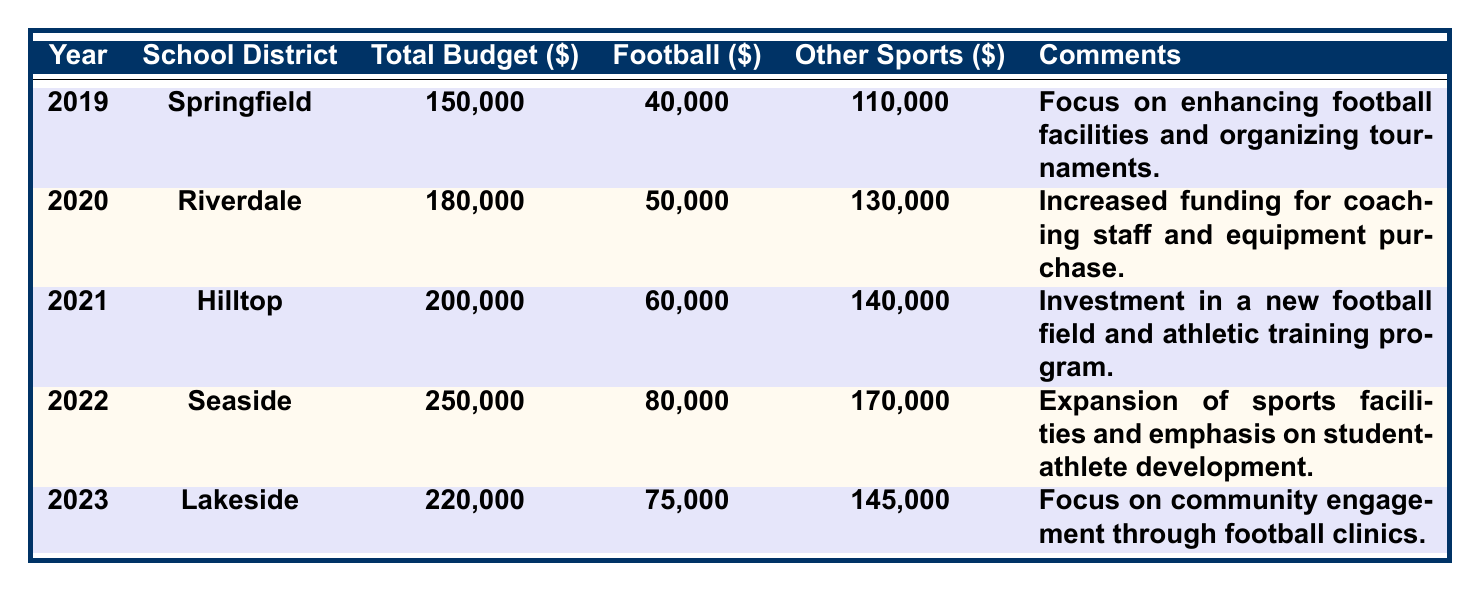What was the total budget for the Seaside School District in 2022? The total budget for the Seaside School District in 2022 is listed in the table under that year, which shows a total budget of $250,000.
Answer: $250,000 How much was allocated to football in 2021? In the year 2021, the table indicates that $60,000 was allocated to football, as shown in the corresponding row.
Answer: $60,000 Which school district had the highest allocation for football in 2022? The table shows that Seaside School District had the highest allocation for football in 2022 with $80,000.
Answer: Seaside School District What was the percentage of the total budget allocated to other sports in 2020? In 2020, the total budget was $180,000 and $130,000 was allocated to other sports. To find the percentage: (130,000 / 180,000) * 100 = 72.22%.
Answer: 72.22% Was the total budget for the Lakeside School District higher in 2023 than the Springfield School District in 2019? The total budget for Lakeside in 2023 is $220,000, while Springfield in 2019 is $150,000. Since 220,000 > 150,000, the statement is true.
Answer: Yes What is the average allocation to football over the five years? The allocations to football are $40,000, $50,000, $60,000, $80,000, and $75,000. The sum is 40,000 + 50,000 + 60,000 + 80,000 + 75,000 = 305,000. The average is 305,000 / 5 = 61,000.
Answer: $61,000 Did the total budget increase every year from 2019 to 2023? The total budgets for each year are 150,000 (2019), 180,000 (2020), 200,000 (2021), 250,000 (2022), and 220,000 (2023). Noticing that there is a decrease from 2022 to 2023, the total budget did not increase every year.
Answer: No Which school district had the lowest total budget in the past five years? By examining the budgets across all listed years, Springfield School District in 2019 had the lowest total budget of $150,000.
Answer: Springfield School District How much more was allocated to other sports than to football in 2022? In 2022, allocation to other sports was $170,000 and to football was $80,000. The difference is 170,000 - 80,000 = 90,000.
Answer: $90,000 What combined total did rugby and basketball receive in 2021? The table does not provide specific allocations for rugby or basketball in 2021, hence this combined total cannot be determined from the provided data.
Answer: Not available 